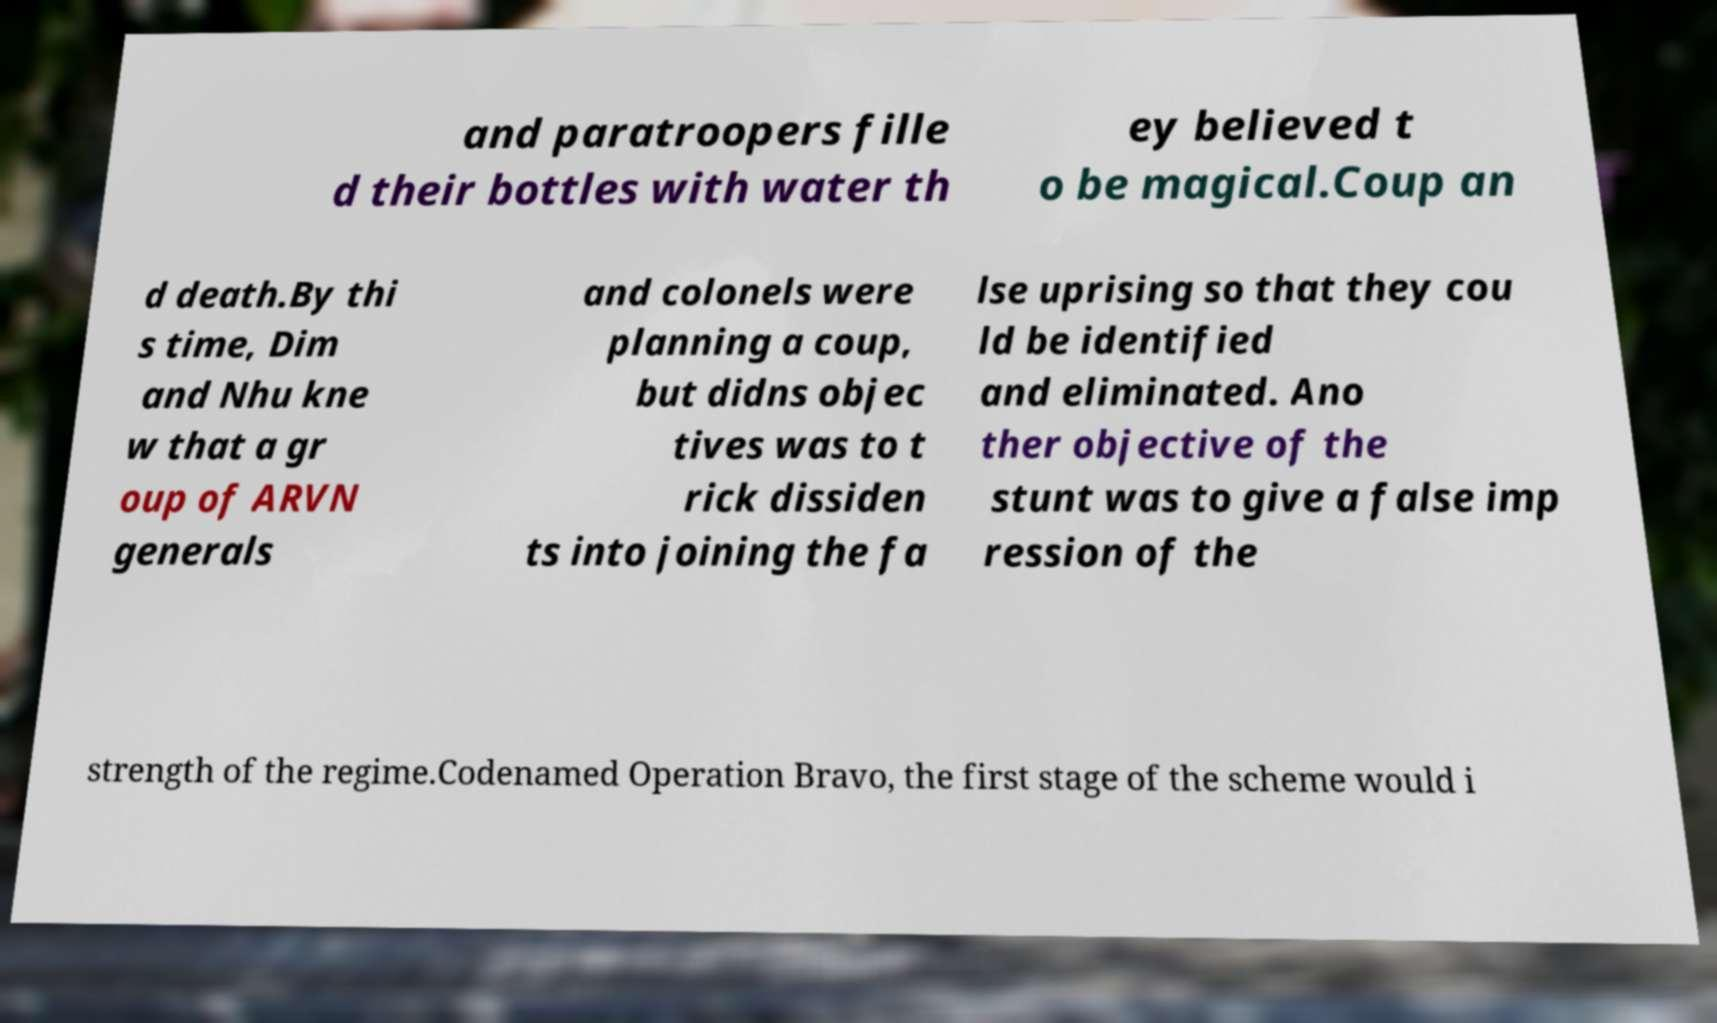I need the written content from this picture converted into text. Can you do that? and paratroopers fille d their bottles with water th ey believed t o be magical.Coup an d death.By thi s time, Dim and Nhu kne w that a gr oup of ARVN generals and colonels were planning a coup, but didns objec tives was to t rick dissiden ts into joining the fa lse uprising so that they cou ld be identified and eliminated. Ano ther objective of the stunt was to give a false imp ression of the strength of the regime.Codenamed Operation Bravo, the first stage of the scheme would i 